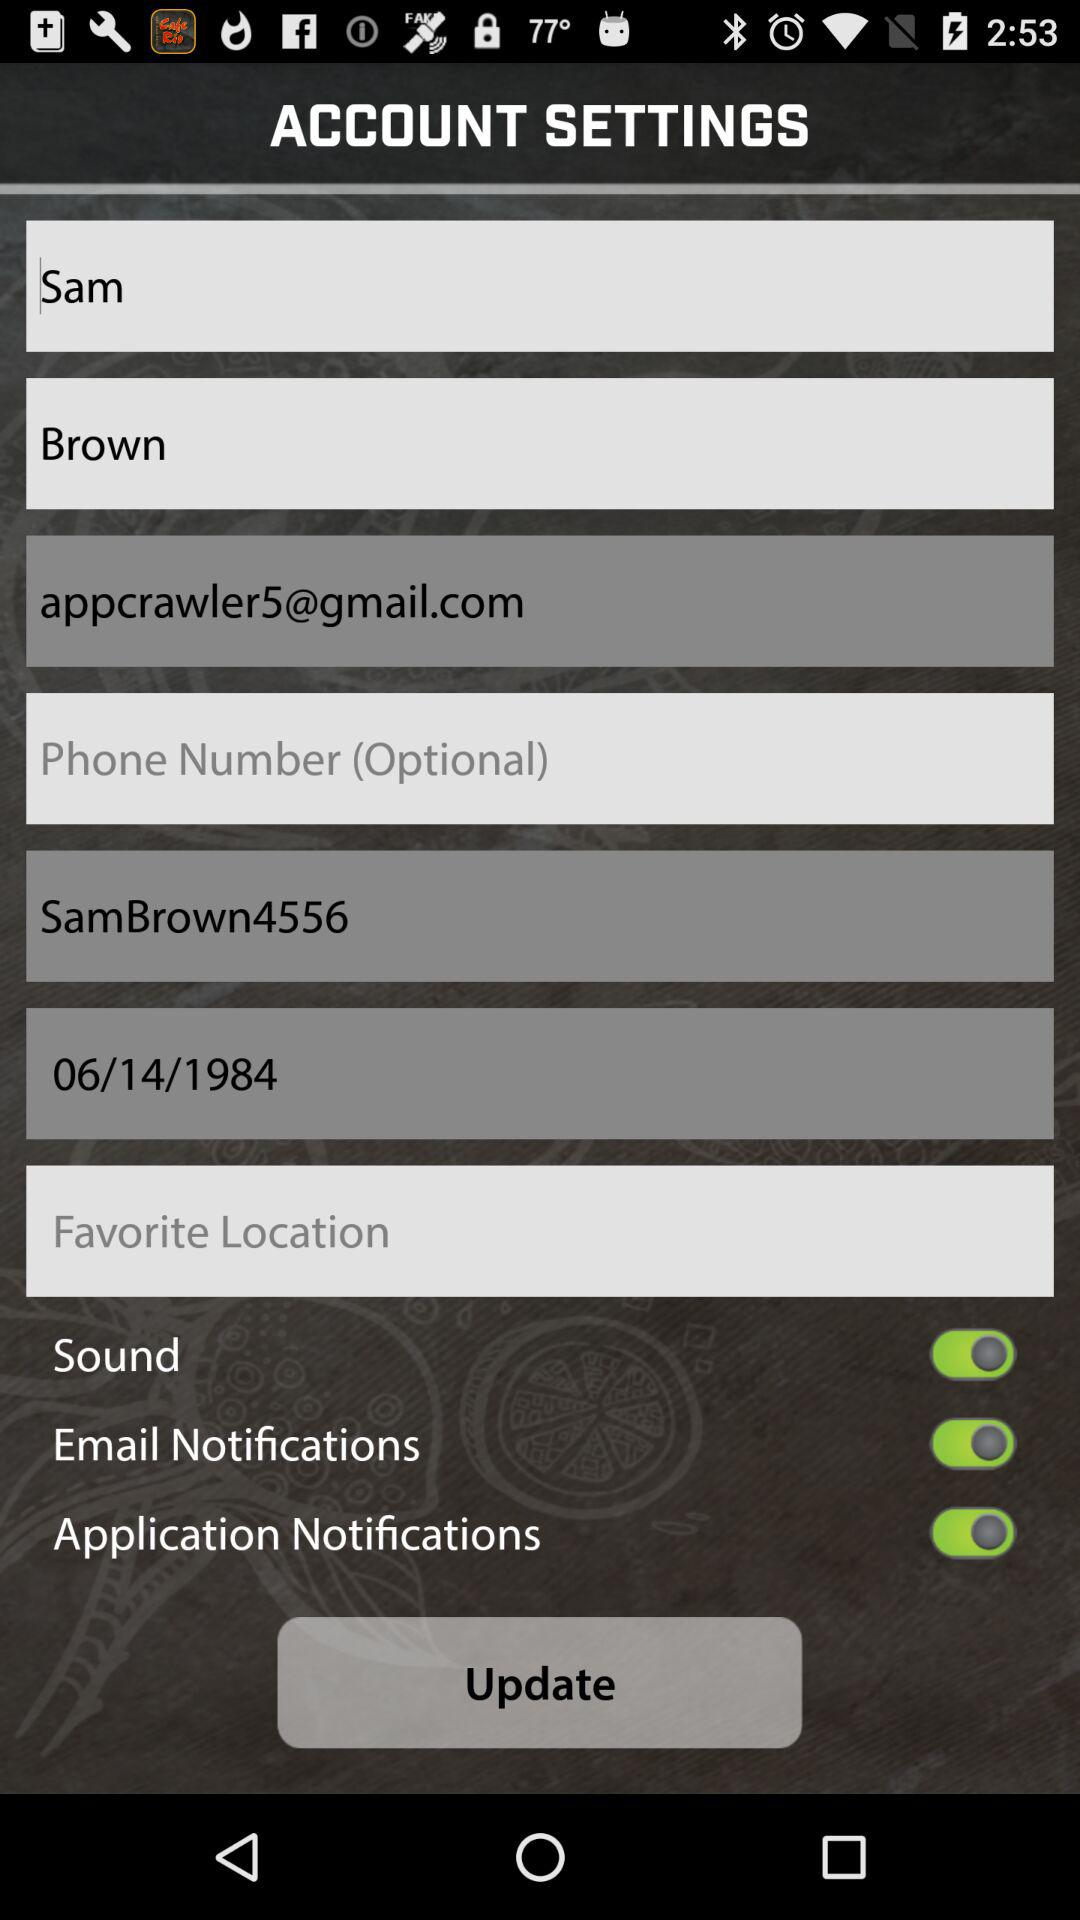What is the user ID? The user ID is "SamBrown4556". 